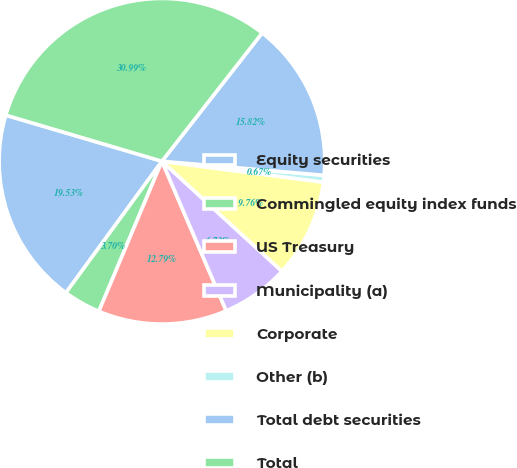Convert chart. <chart><loc_0><loc_0><loc_500><loc_500><pie_chart><fcel>Equity securities<fcel>Commingled equity index funds<fcel>US Treasury<fcel>Municipality (a)<fcel>Corporate<fcel>Other (b)<fcel>Total debt securities<fcel>Total<nl><fcel>19.53%<fcel>3.7%<fcel>12.79%<fcel>6.73%<fcel>9.76%<fcel>0.67%<fcel>15.82%<fcel>30.98%<nl></chart> 